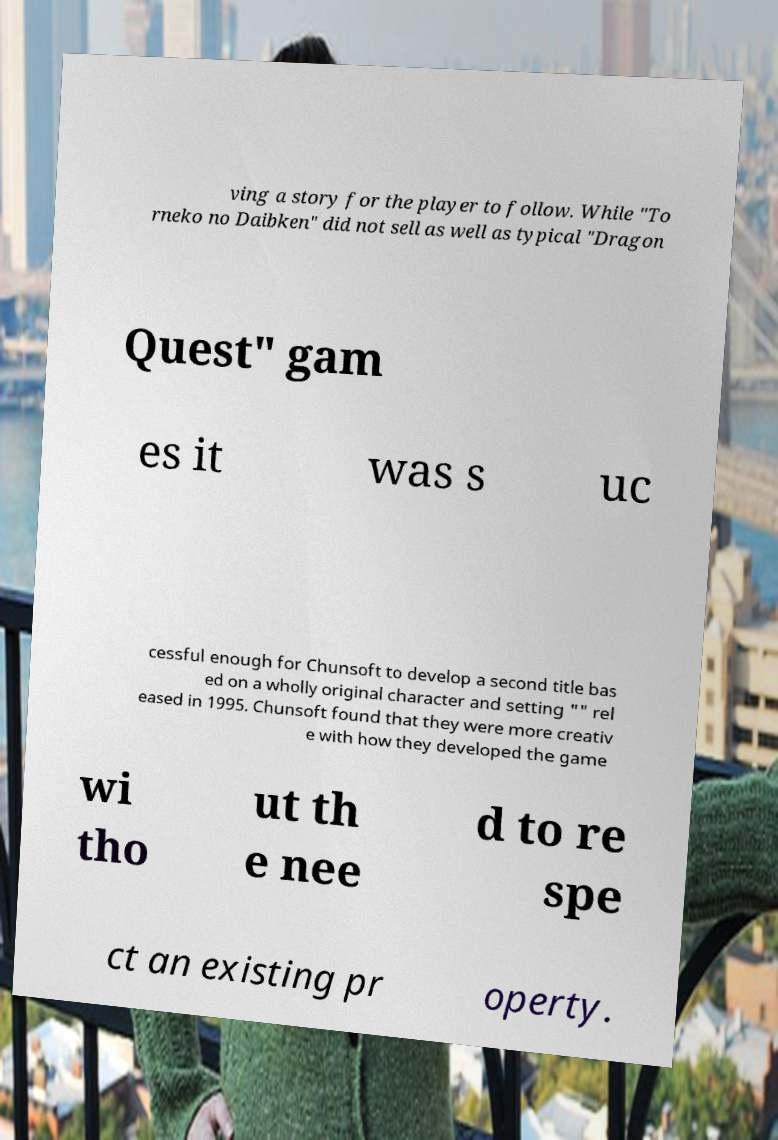Could you assist in decoding the text presented in this image and type it out clearly? ving a story for the player to follow. While "To rneko no Daibken" did not sell as well as typical "Dragon Quest" gam es it was s uc cessful enough for Chunsoft to develop a second title bas ed on a wholly original character and setting "" rel eased in 1995. Chunsoft found that they were more creativ e with how they developed the game wi tho ut th e nee d to re spe ct an existing pr operty. 